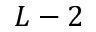Convert formula to latex. <formula><loc_0><loc_0><loc_500><loc_500>L - 2</formula> 